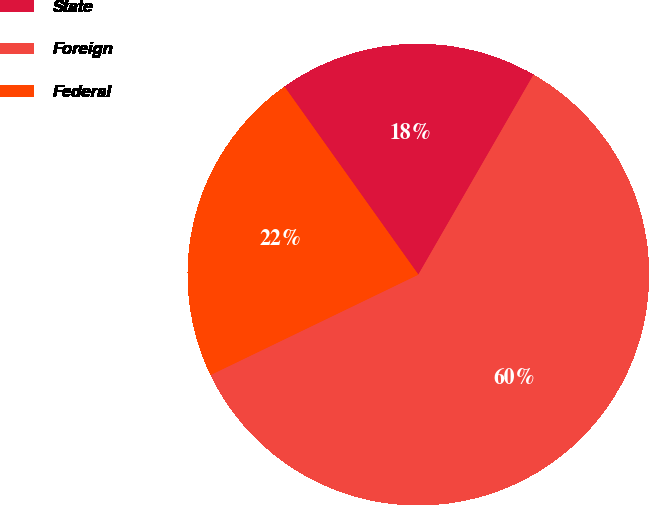Convert chart. <chart><loc_0><loc_0><loc_500><loc_500><pie_chart><fcel>State<fcel>Foreign<fcel>Federal<nl><fcel>18.17%<fcel>59.52%<fcel>22.31%<nl></chart> 